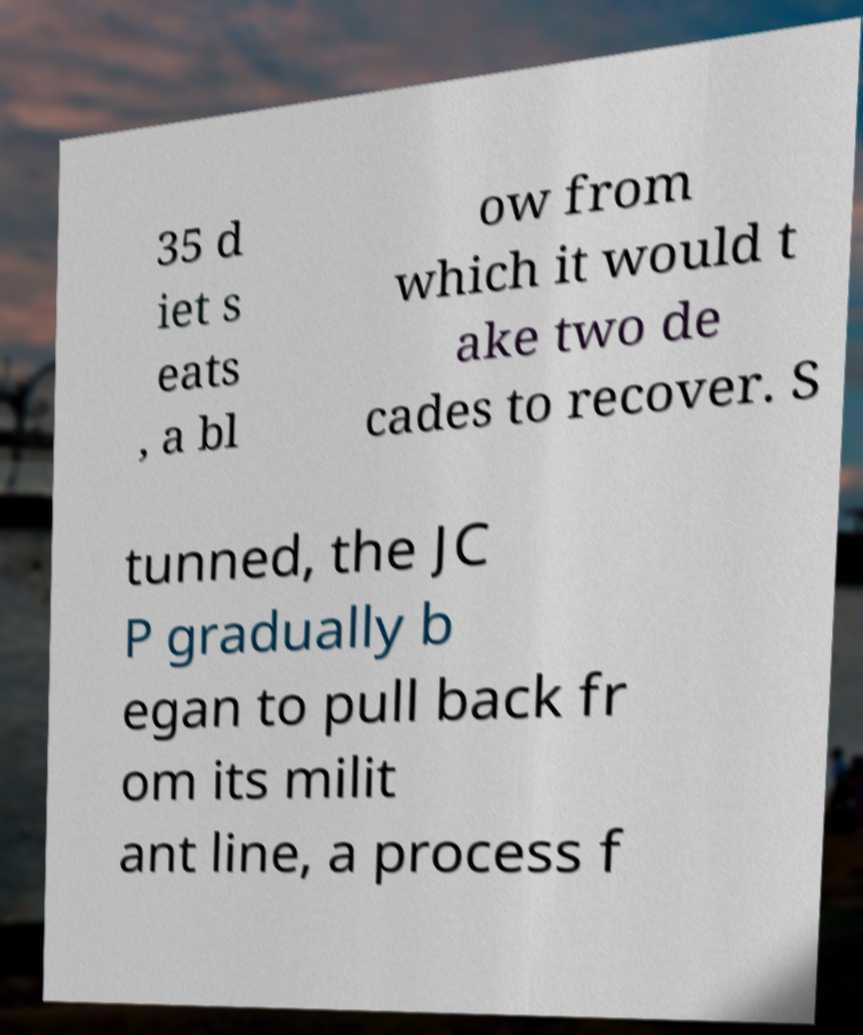What messages or text are displayed in this image? I need them in a readable, typed format. 35 d iet s eats , a bl ow from which it would t ake two de cades to recover. S tunned, the JC P gradually b egan to pull back fr om its milit ant line, a process f 